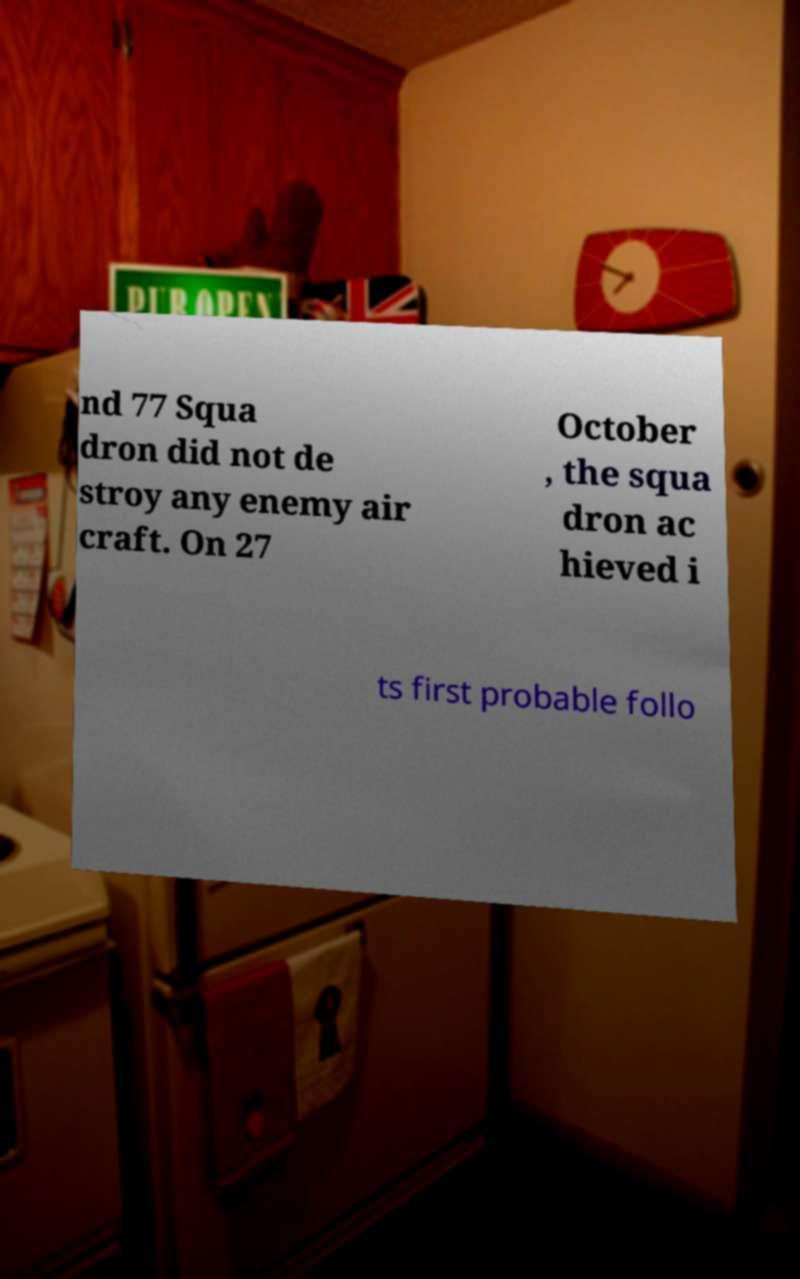What messages or text are displayed in this image? I need them in a readable, typed format. nd 77 Squa dron did not de stroy any enemy air craft. On 27 October , the squa dron ac hieved i ts first probable follo 